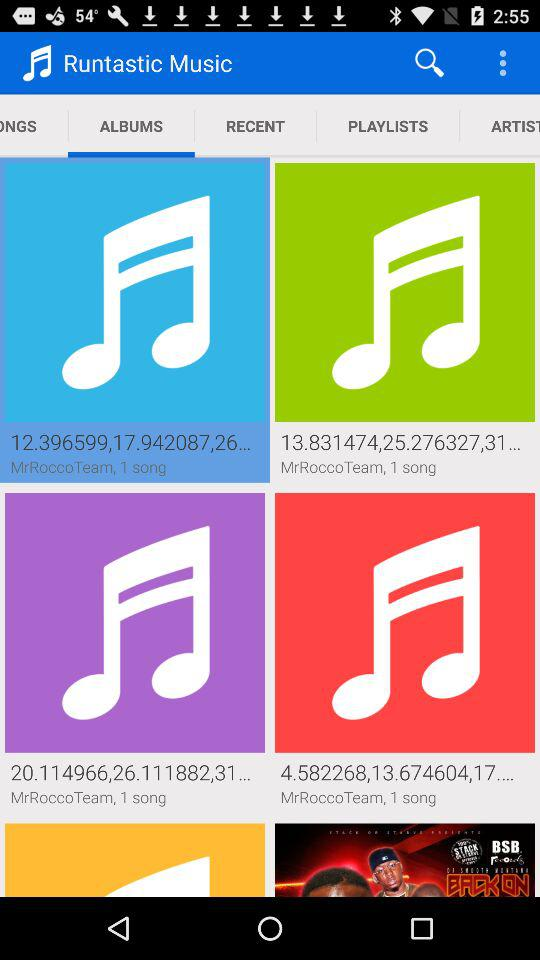What is the application name? The application name is "Runtastic Music". 